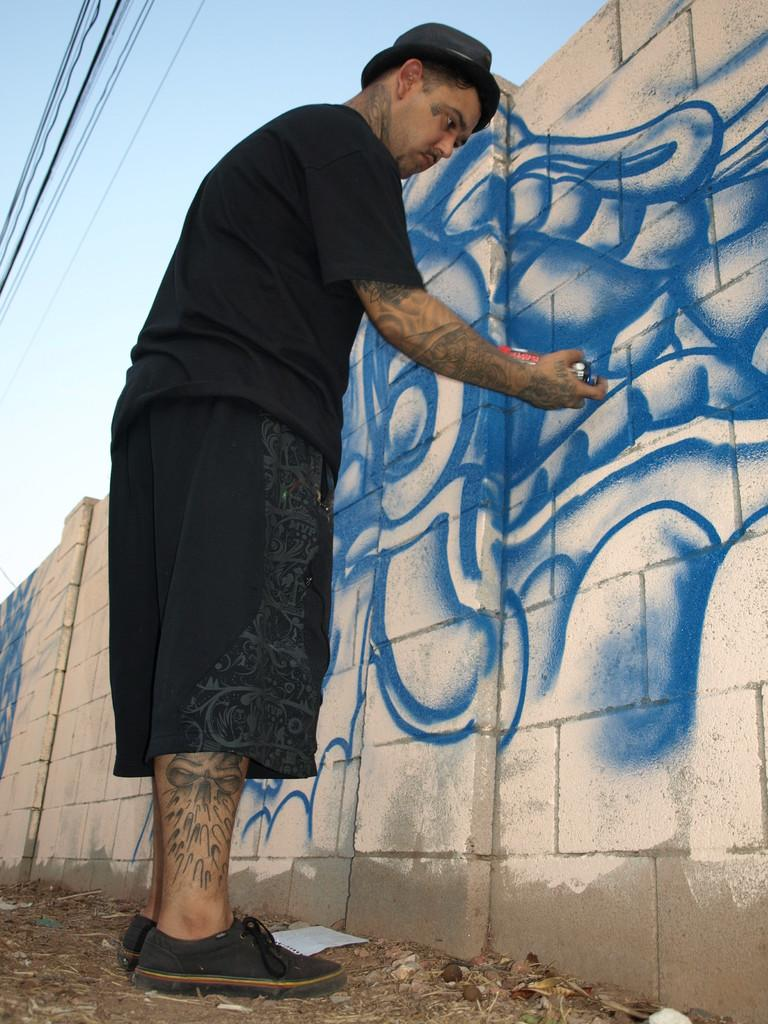What is the person in the image doing? The person is painting a wall. What is the person holding in the image? The person is holding an object, which is likely a paintbrush or paint roller. What can be seen at the top of the image? There are wires and the sky visible at the top of the image. How many ladybugs are crawling on the person's arm in the image? There are no ladybugs present in the image. What type of surprise is the person about to reveal in the image? There is no indication of a surprise in the image. 